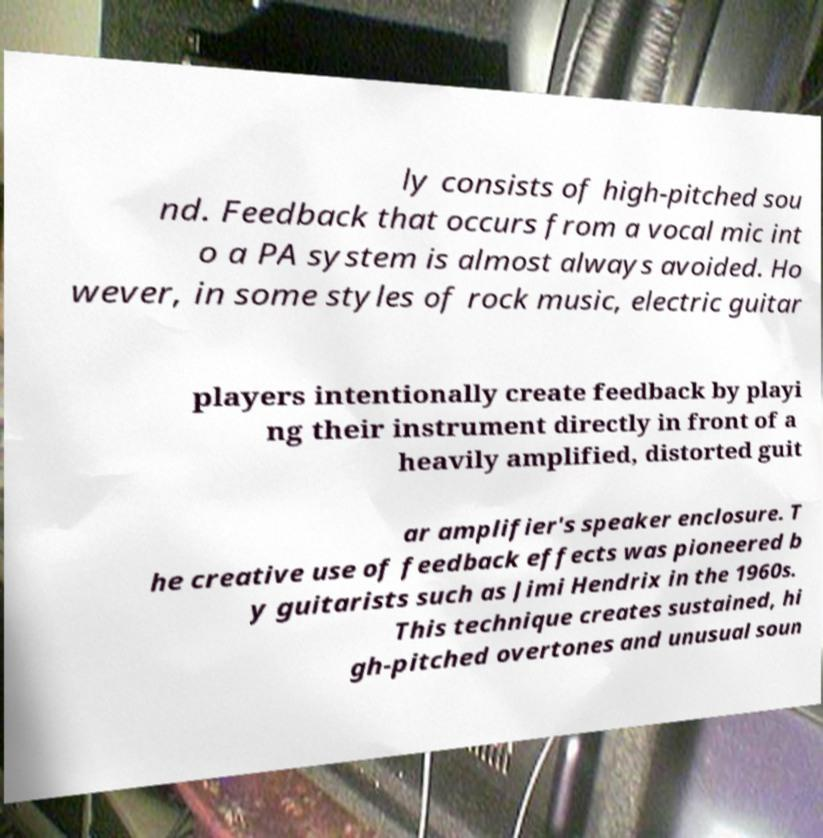There's text embedded in this image that I need extracted. Can you transcribe it verbatim? ly consists of high-pitched sou nd. Feedback that occurs from a vocal mic int o a PA system is almost always avoided. Ho wever, in some styles of rock music, electric guitar players intentionally create feedback by playi ng their instrument directly in front of a heavily amplified, distorted guit ar amplifier's speaker enclosure. T he creative use of feedback effects was pioneered b y guitarists such as Jimi Hendrix in the 1960s. This technique creates sustained, hi gh-pitched overtones and unusual soun 